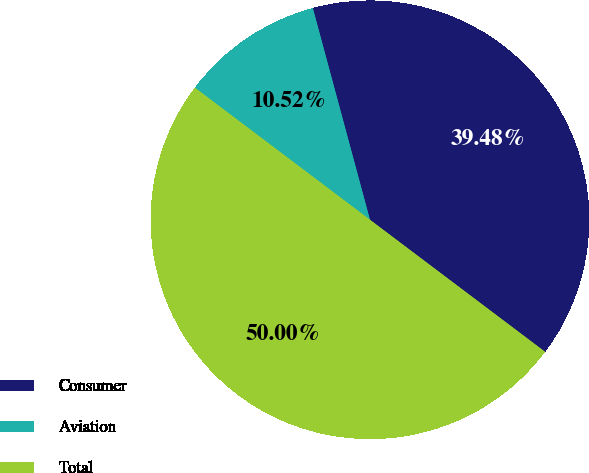<chart> <loc_0><loc_0><loc_500><loc_500><pie_chart><fcel>Consumer<fcel>Aviation<fcel>Total<nl><fcel>39.48%<fcel>10.52%<fcel>50.0%<nl></chart> 